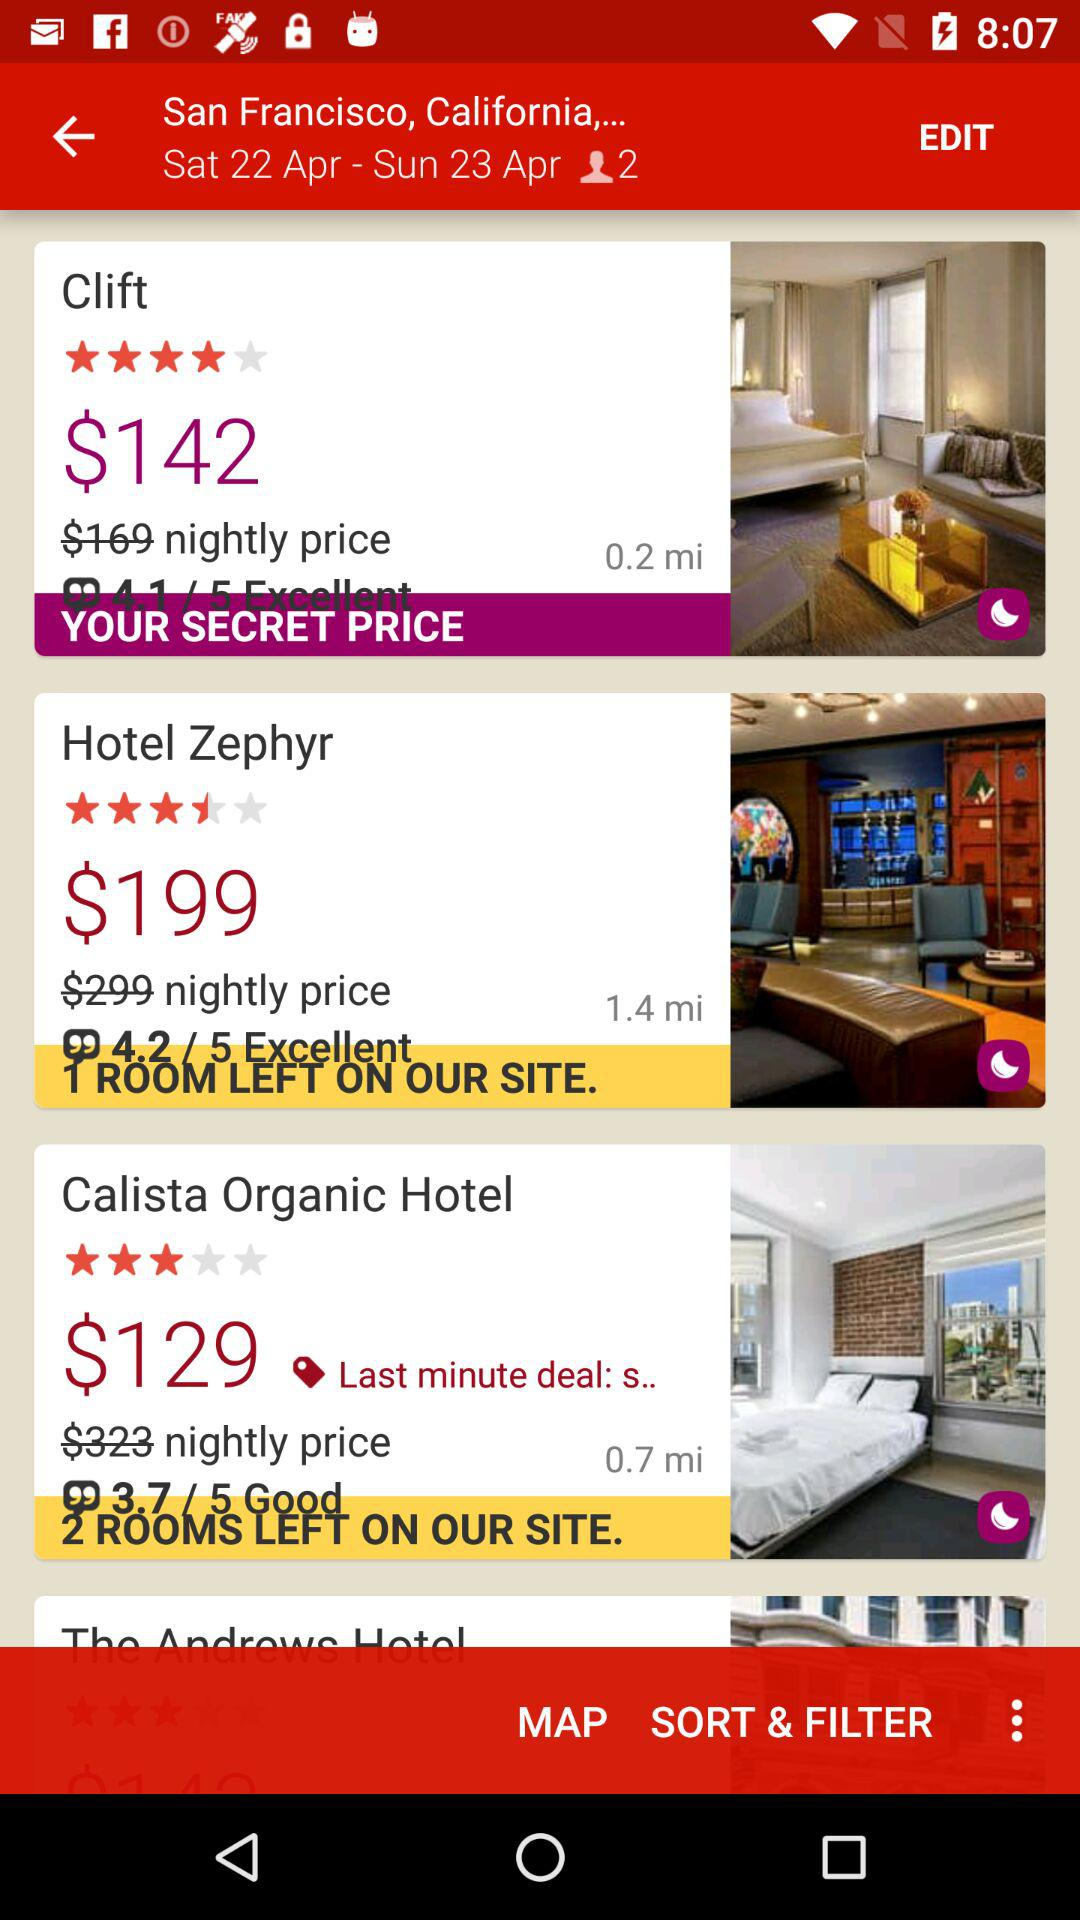Which hotel has the best rating? The hotel that has the best rating is "Clift". 